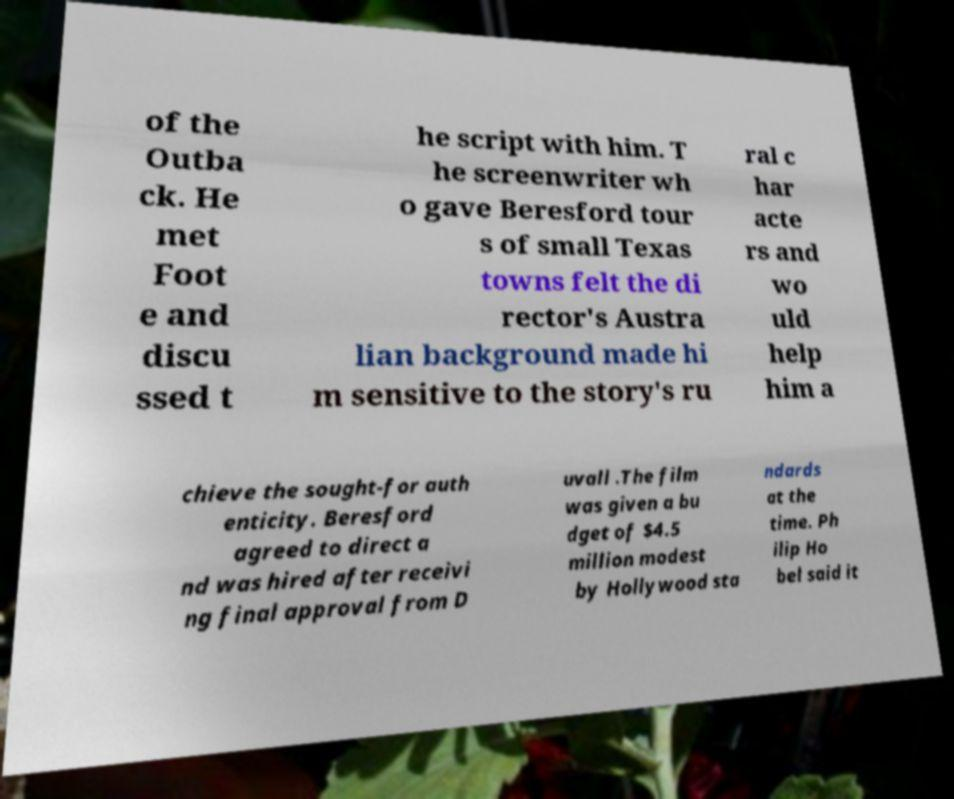I need the written content from this picture converted into text. Can you do that? of the Outba ck. He met Foot e and discu ssed t he script with him. T he screenwriter wh o gave Beresford tour s of small Texas towns felt the di rector's Austra lian background made hi m sensitive to the story's ru ral c har acte rs and wo uld help him a chieve the sought-for auth enticity. Beresford agreed to direct a nd was hired after receivi ng final approval from D uvall .The film was given a bu dget of $4.5 million modest by Hollywood sta ndards at the time. Ph ilip Ho bel said it 